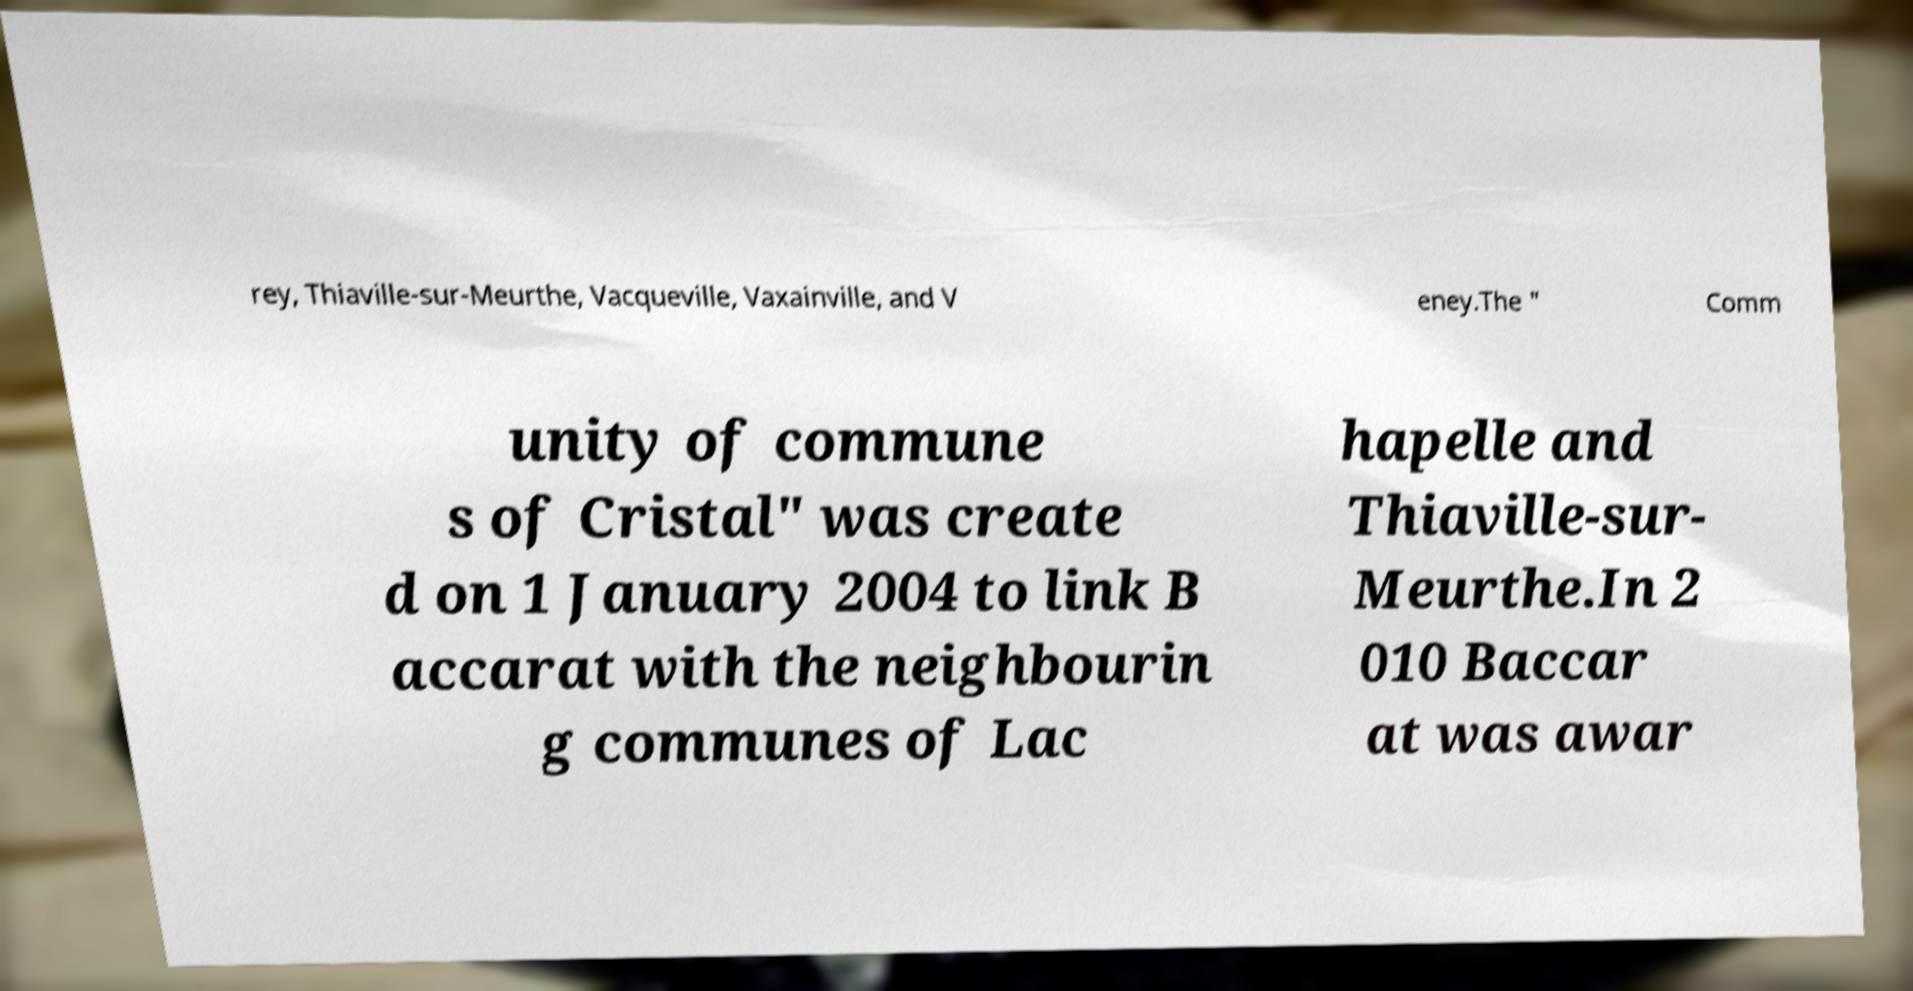I need the written content from this picture converted into text. Can you do that? rey, Thiaville-sur-Meurthe, Vacqueville, Vaxainville, and V eney.The " Comm unity of commune s of Cristal" was create d on 1 January 2004 to link B accarat with the neighbourin g communes of Lac hapelle and Thiaville-sur- Meurthe.In 2 010 Baccar at was awar 